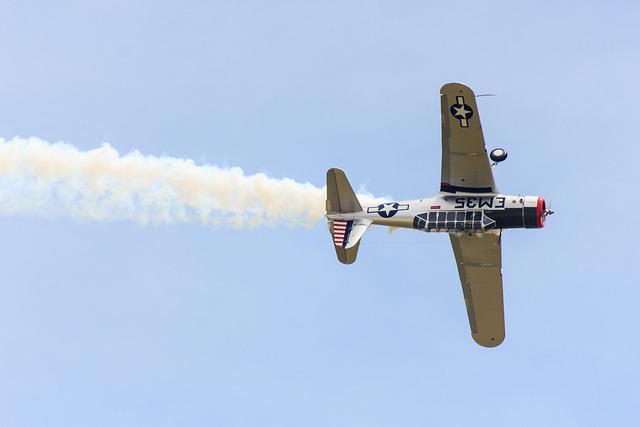<image>What is coming out of the back of the airplane? I am not sure what is coming out of the back of the airplane. It could be smoke or exhaust. What is coming out of the back of the airplane? I don't know what is coming out of the back of the airplane. It can be smoke or exhaust. 